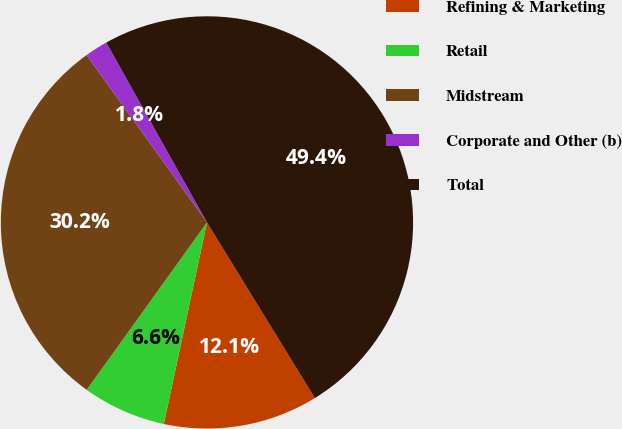<chart> <loc_0><loc_0><loc_500><loc_500><pie_chart><fcel>Refining & Marketing<fcel>Retail<fcel>Midstream<fcel>Corporate and Other (b)<fcel>Total<nl><fcel>12.12%<fcel>6.56%<fcel>30.16%<fcel>1.8%<fcel>49.36%<nl></chart> 